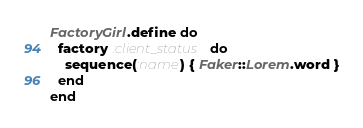<code> <loc_0><loc_0><loc_500><loc_500><_Ruby_>FactoryGirl.define do
  factory :client_status do
    sequence(:name) { Faker::Lorem.word }
  end
end
</code> 